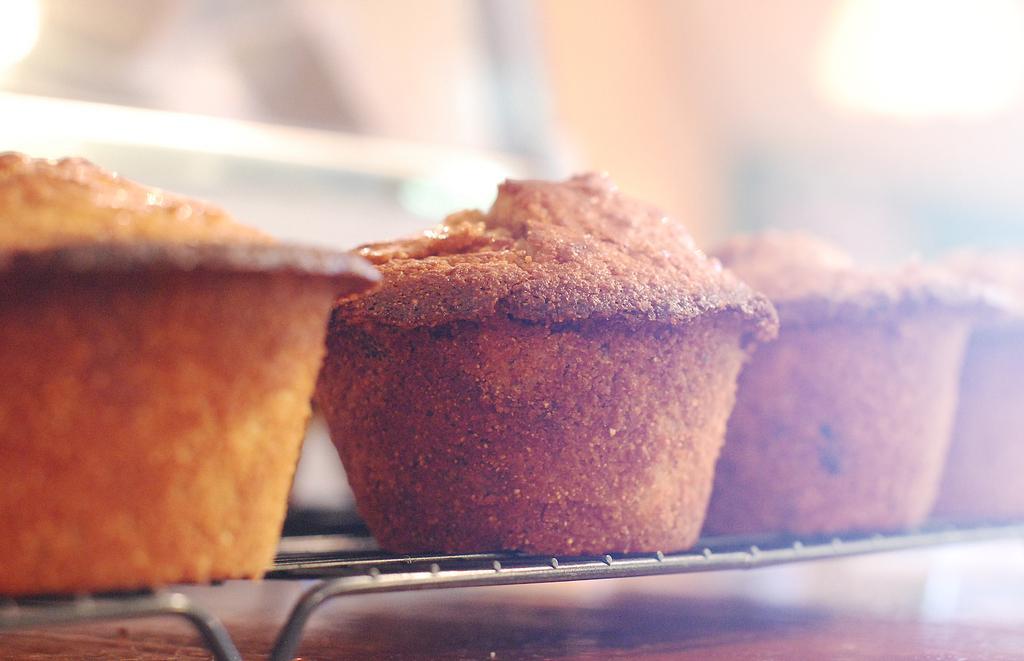Please provide a concise description of this image. In this image, we can see cupcakes. In the background, image is blurred. 